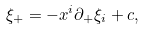Convert formula to latex. <formula><loc_0><loc_0><loc_500><loc_500>\xi _ { + } = - x ^ { i } \partial _ { + } \xi _ { i } + c ,</formula> 